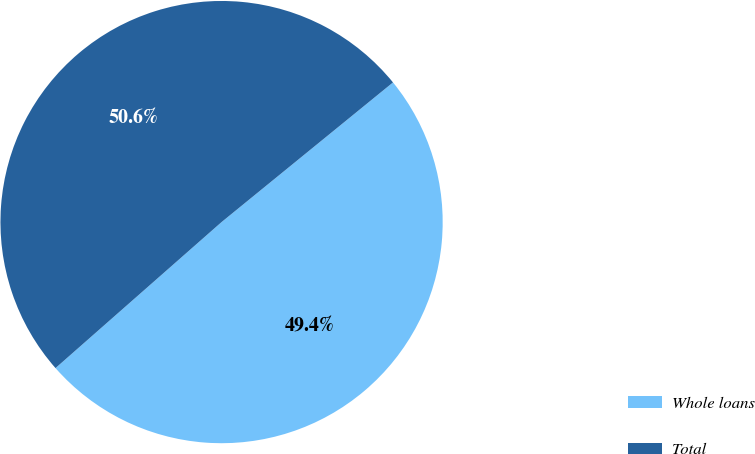<chart> <loc_0><loc_0><loc_500><loc_500><pie_chart><fcel>Whole loans<fcel>Total<nl><fcel>49.4%<fcel>50.6%<nl></chart> 